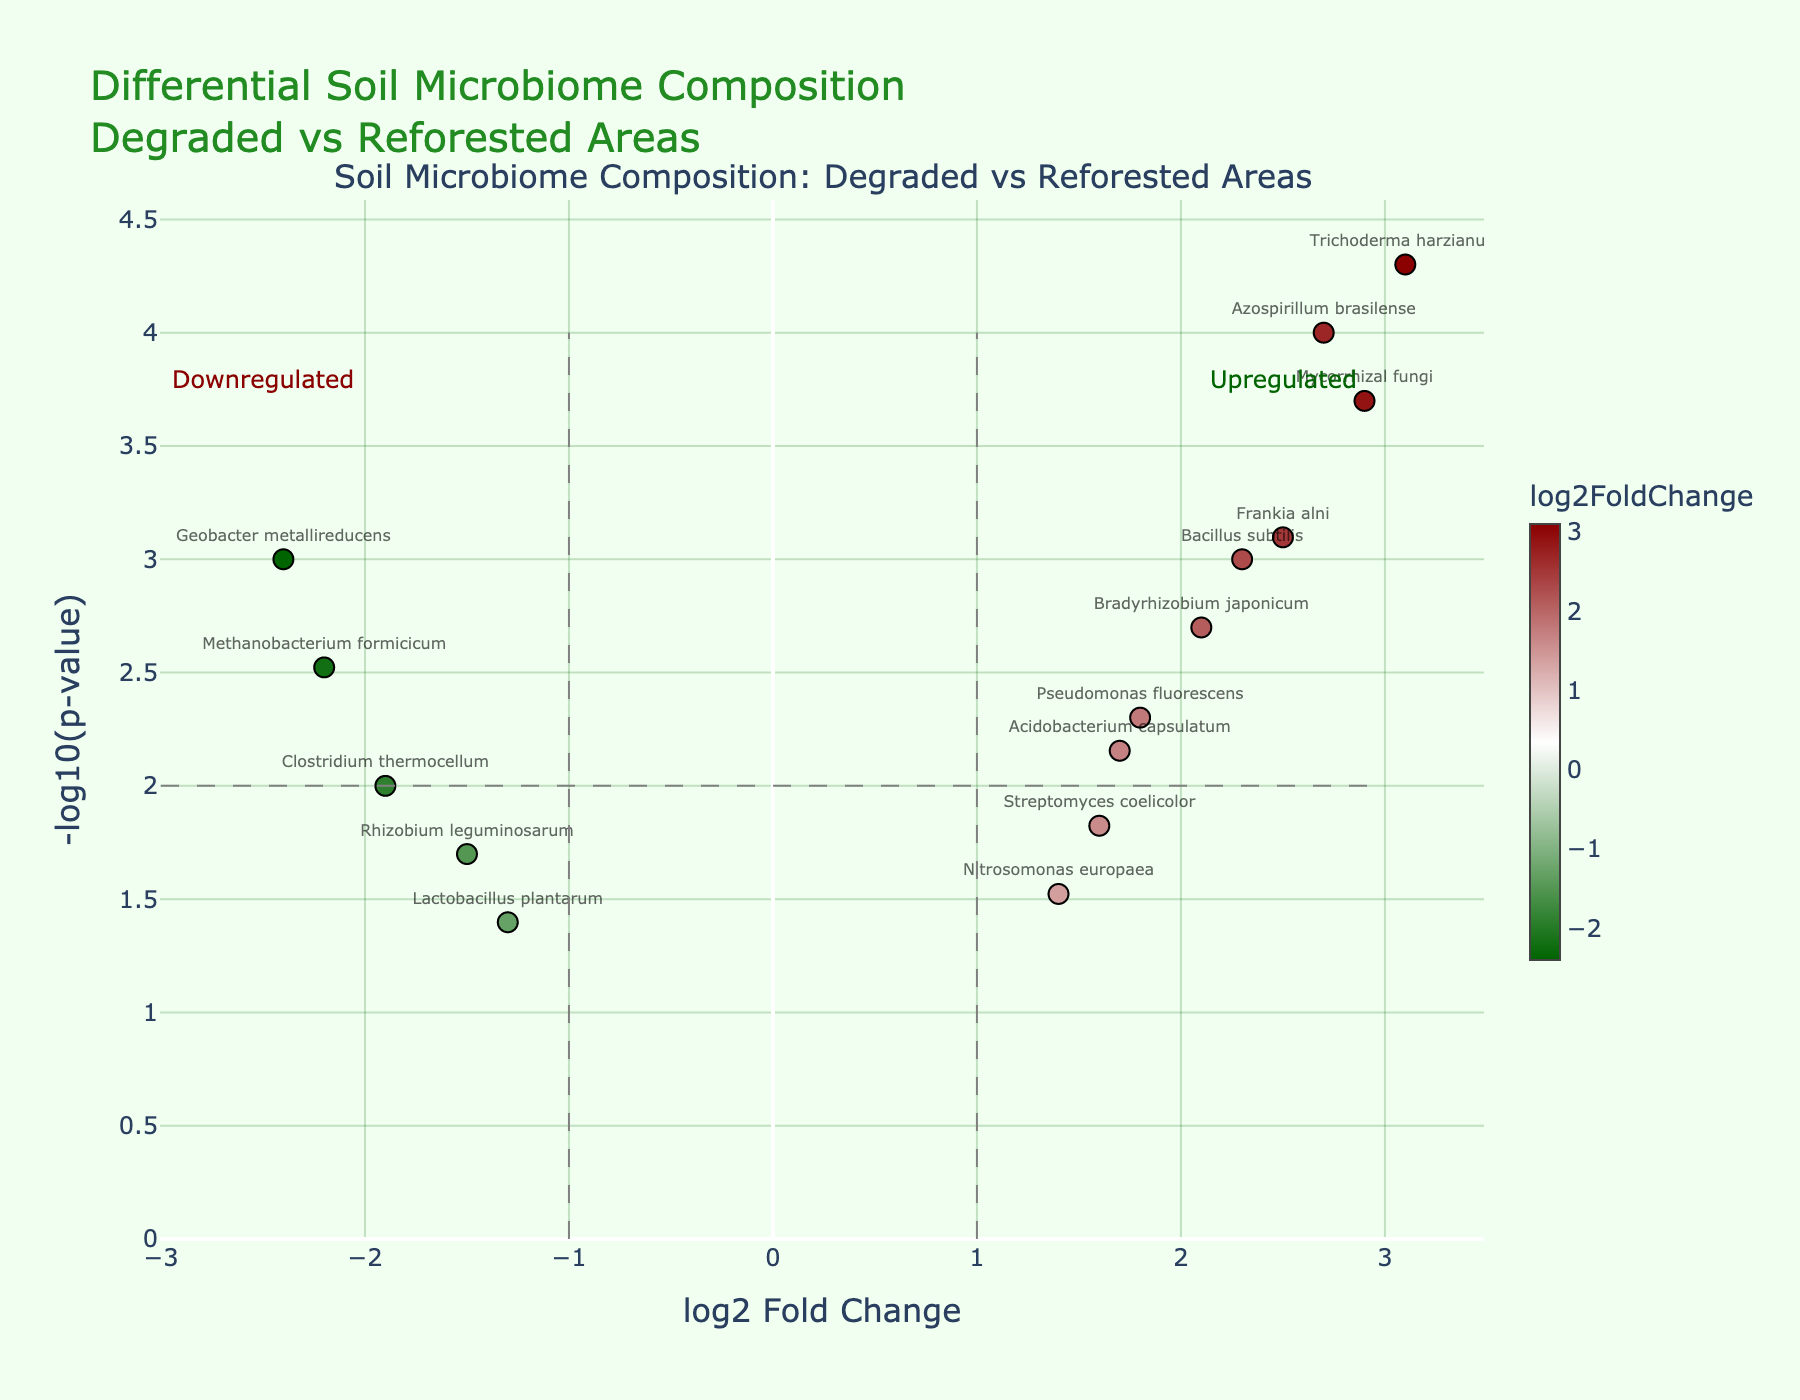Which microorganisms exhibit the most significant upregulation? The most significantly upregulated microorganisms can be identified by looking at the points that are farthest to the right and highest on the plot, indicating the highest log2FoldChange and the lowest p-values. Azospirillum brasilense, Trichoderma harzianum, and Mycorrhizal fungi are the most significantly upregulated.
Answer: Azospirillum brasilense, Trichoderma harzianum, Mycorrhizal fungi Which microorganism shows the highest log2FoldChange and what is its p-value? To find the microorganism with the highest log2FoldChange, look for the point furthest to the right on the x-axis. The microorganism is Trichoderma harzianum, with a p-value of 0.00005.
Answer: Trichoderma harzianum, 0.00005 How many microorganisms have a log2FoldChange greater than 1? Count the number of points to the right of the vertical line at log2FoldChange = 1. The points are: Bacillus subtilis, Pseudomonas fluorescens, Azospirillum brasilense, Trichoderma harzianum, Mycorrhizal fungi, Bradyrhizobium japonicum, Frankia alni, Acidobacterium capsulatum, and Streptomyces coelicolor.
Answer: 9 Which microorganisms are significantly downregulated? Significantly downregulated microorganisms have a log2FoldChange less than -1 and a small p-value (high -log10(p-value)). Methanobacterium formicicum, Clostridium thermocellum, Lactobacillus plantarum, and Geobacter metallireducens fit these criteria.
Answer: Methanobacterium formicicum, Clostridium thermocellum, Lactobacillus plantarum, Geobacter metallireducens What is the relationship between the upregulation of Mycorrhizal fungi and Bradyrhizobium japonicum? Compare the log2FoldChange and p-value of both microorganisms. Both are upregulated significantly, with Mycorrhizal fungi having a higher log2FoldChange (2.9) compared to Bradyrhizobium japonicum (2.1), and a lower p-value (0.0002 vs. 0.002).
Answer: Mycorrhizal fungi is more upregulated compared to Bradyrhizobium japonicum What fold change threshold is used in the plot to categorize upregulation and downregulation? Check the vertical lines that are used as thresholds. The solid lines at log2FoldChange = 1 and log2FoldChange = -1 are the thresholds used.
Answer: log2FoldChange = 1 and -1 Which microorganism has the lowest p-value and how is this indicated in the plot? The microorganism with the lowest p-value will be highest on the y-axis (-log10(p-value)). Trichoderma harzianum, located at approximately 4.3 on the y-axis, has the lowest p-value.
Answer: Trichoderma harzianum What percentage of the microorganisms fall into the significantly regulated categories (either upregulated or downregulated)? Count all the data points and the data points that fall to the left of log2FoldChange = -1 or to the right of log2FoldChange = 1. There are 15 microorganisms in total, 4 downregulated, 9 upregulated. Thus, (4 + 9) / 15 * 100% = 86.67%.
Answer: 86.67% Is there a clear distinction in microbiome composition between degraded and reforested areas based on this plot? Evaluate the spread and clustering of points around the vertical thresholds and significance lines. There is a clear distinction, with significant clustering of microorganisms showing both upregulation and downregulation in reforested areas compared to degraded ones.
Answer: Yes 